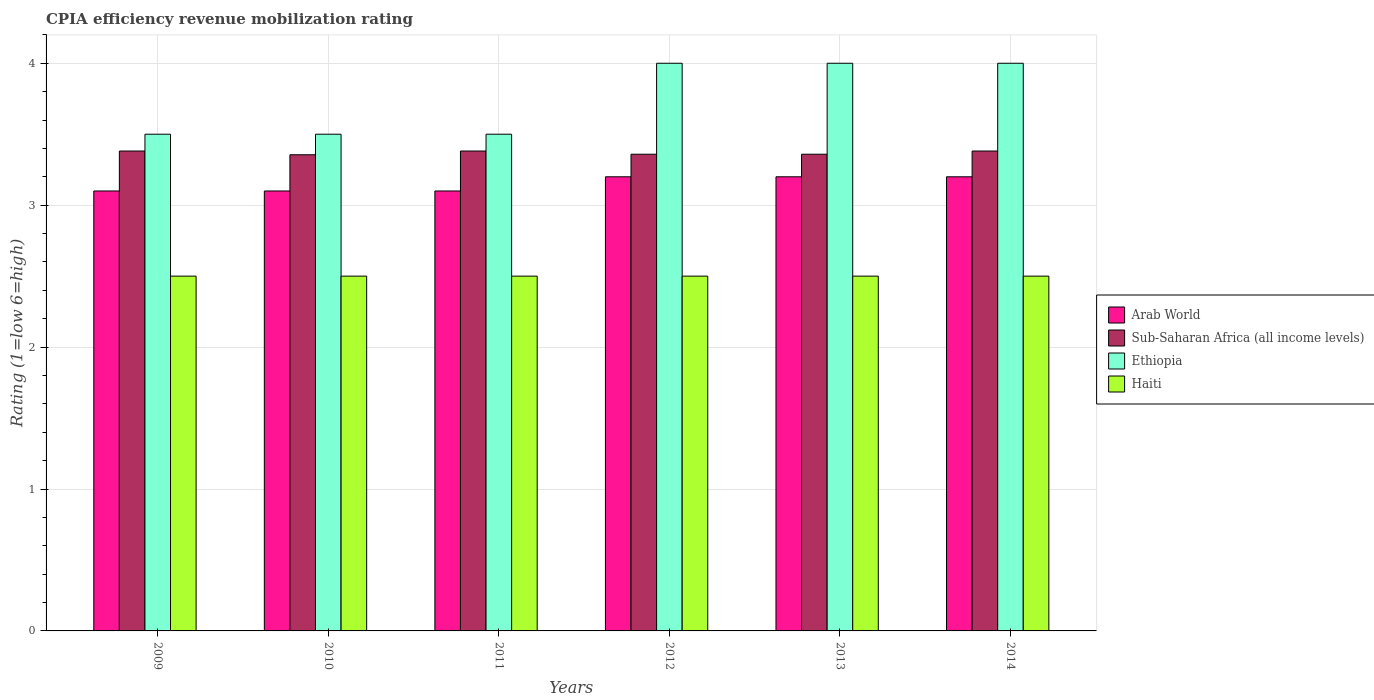How many different coloured bars are there?
Provide a short and direct response. 4. Are the number of bars per tick equal to the number of legend labels?
Give a very brief answer. Yes. Are the number of bars on each tick of the X-axis equal?
Provide a succinct answer. Yes. How many bars are there on the 6th tick from the right?
Provide a succinct answer. 4. What is the label of the 2nd group of bars from the left?
Your answer should be very brief. 2010. Across all years, what is the maximum CPIA rating in Sub-Saharan Africa (all income levels)?
Your response must be concise. 3.38. What is the total CPIA rating in Sub-Saharan Africa (all income levels) in the graph?
Provide a short and direct response. 20.22. What is the difference between the CPIA rating in Ethiopia in 2010 and that in 2012?
Your answer should be very brief. -0.5. What is the difference between the CPIA rating in Haiti in 2014 and the CPIA rating in Sub-Saharan Africa (all income levels) in 2009?
Your answer should be compact. -0.88. In how many years, is the CPIA rating in Sub-Saharan Africa (all income levels) greater than 3.2?
Offer a terse response. 6. What is the difference between the highest and the lowest CPIA rating in Arab World?
Make the answer very short. 0.1. In how many years, is the CPIA rating in Arab World greater than the average CPIA rating in Arab World taken over all years?
Keep it short and to the point. 3. Is it the case that in every year, the sum of the CPIA rating in Haiti and CPIA rating in Sub-Saharan Africa (all income levels) is greater than the sum of CPIA rating in Ethiopia and CPIA rating in Arab World?
Ensure brevity in your answer.  No. What does the 2nd bar from the left in 2014 represents?
Keep it short and to the point. Sub-Saharan Africa (all income levels). What does the 3rd bar from the right in 2012 represents?
Give a very brief answer. Sub-Saharan Africa (all income levels). Is it the case that in every year, the sum of the CPIA rating in Sub-Saharan Africa (all income levels) and CPIA rating in Arab World is greater than the CPIA rating in Haiti?
Make the answer very short. Yes. How many bars are there?
Ensure brevity in your answer.  24. What is the difference between two consecutive major ticks on the Y-axis?
Ensure brevity in your answer.  1. Are the values on the major ticks of Y-axis written in scientific E-notation?
Ensure brevity in your answer.  No. How many legend labels are there?
Give a very brief answer. 4. What is the title of the graph?
Ensure brevity in your answer.  CPIA efficiency revenue mobilization rating. Does "Uzbekistan" appear as one of the legend labels in the graph?
Give a very brief answer. No. What is the Rating (1=low 6=high) in Sub-Saharan Africa (all income levels) in 2009?
Give a very brief answer. 3.38. What is the Rating (1=low 6=high) of Ethiopia in 2009?
Ensure brevity in your answer.  3.5. What is the Rating (1=low 6=high) in Haiti in 2009?
Offer a very short reply. 2.5. What is the Rating (1=low 6=high) in Arab World in 2010?
Your answer should be compact. 3.1. What is the Rating (1=low 6=high) in Sub-Saharan Africa (all income levels) in 2010?
Offer a very short reply. 3.36. What is the Rating (1=low 6=high) of Sub-Saharan Africa (all income levels) in 2011?
Offer a very short reply. 3.38. What is the Rating (1=low 6=high) in Haiti in 2011?
Provide a short and direct response. 2.5. What is the Rating (1=low 6=high) of Sub-Saharan Africa (all income levels) in 2012?
Ensure brevity in your answer.  3.36. What is the Rating (1=low 6=high) of Ethiopia in 2012?
Your answer should be compact. 4. What is the Rating (1=low 6=high) of Arab World in 2013?
Make the answer very short. 3.2. What is the Rating (1=low 6=high) of Sub-Saharan Africa (all income levels) in 2013?
Your response must be concise. 3.36. What is the Rating (1=low 6=high) in Haiti in 2013?
Your answer should be compact. 2.5. What is the Rating (1=low 6=high) in Sub-Saharan Africa (all income levels) in 2014?
Your response must be concise. 3.38. Across all years, what is the maximum Rating (1=low 6=high) of Arab World?
Ensure brevity in your answer.  3.2. Across all years, what is the maximum Rating (1=low 6=high) of Sub-Saharan Africa (all income levels)?
Your answer should be compact. 3.38. Across all years, what is the maximum Rating (1=low 6=high) of Haiti?
Offer a very short reply. 2.5. Across all years, what is the minimum Rating (1=low 6=high) in Arab World?
Offer a very short reply. 3.1. Across all years, what is the minimum Rating (1=low 6=high) of Sub-Saharan Africa (all income levels)?
Your response must be concise. 3.36. Across all years, what is the minimum Rating (1=low 6=high) in Ethiopia?
Give a very brief answer. 3.5. Across all years, what is the minimum Rating (1=low 6=high) in Haiti?
Ensure brevity in your answer.  2.5. What is the total Rating (1=low 6=high) in Arab World in the graph?
Give a very brief answer. 18.9. What is the total Rating (1=low 6=high) in Sub-Saharan Africa (all income levels) in the graph?
Offer a very short reply. 20.22. What is the total Rating (1=low 6=high) in Haiti in the graph?
Keep it short and to the point. 15. What is the difference between the Rating (1=low 6=high) in Arab World in 2009 and that in 2010?
Keep it short and to the point. 0. What is the difference between the Rating (1=low 6=high) in Sub-Saharan Africa (all income levels) in 2009 and that in 2010?
Provide a short and direct response. 0.03. What is the difference between the Rating (1=low 6=high) in Ethiopia in 2009 and that in 2010?
Make the answer very short. 0. What is the difference between the Rating (1=low 6=high) of Ethiopia in 2009 and that in 2011?
Give a very brief answer. 0. What is the difference between the Rating (1=low 6=high) of Sub-Saharan Africa (all income levels) in 2009 and that in 2012?
Offer a terse response. 0.02. What is the difference between the Rating (1=low 6=high) in Haiti in 2009 and that in 2012?
Your answer should be very brief. 0. What is the difference between the Rating (1=low 6=high) in Arab World in 2009 and that in 2013?
Ensure brevity in your answer.  -0.1. What is the difference between the Rating (1=low 6=high) of Sub-Saharan Africa (all income levels) in 2009 and that in 2013?
Keep it short and to the point. 0.02. What is the difference between the Rating (1=low 6=high) of Ethiopia in 2009 and that in 2013?
Ensure brevity in your answer.  -0.5. What is the difference between the Rating (1=low 6=high) in Haiti in 2009 and that in 2013?
Provide a succinct answer. 0. What is the difference between the Rating (1=low 6=high) of Arab World in 2009 and that in 2014?
Provide a short and direct response. -0.1. What is the difference between the Rating (1=low 6=high) in Ethiopia in 2009 and that in 2014?
Offer a very short reply. -0.5. What is the difference between the Rating (1=low 6=high) in Haiti in 2009 and that in 2014?
Provide a succinct answer. 0. What is the difference between the Rating (1=low 6=high) of Sub-Saharan Africa (all income levels) in 2010 and that in 2011?
Your answer should be very brief. -0.03. What is the difference between the Rating (1=low 6=high) of Ethiopia in 2010 and that in 2011?
Ensure brevity in your answer.  0. What is the difference between the Rating (1=low 6=high) in Haiti in 2010 and that in 2011?
Your response must be concise. 0. What is the difference between the Rating (1=low 6=high) in Arab World in 2010 and that in 2012?
Your response must be concise. -0.1. What is the difference between the Rating (1=low 6=high) of Sub-Saharan Africa (all income levels) in 2010 and that in 2012?
Give a very brief answer. -0. What is the difference between the Rating (1=low 6=high) in Ethiopia in 2010 and that in 2012?
Ensure brevity in your answer.  -0.5. What is the difference between the Rating (1=low 6=high) of Haiti in 2010 and that in 2012?
Make the answer very short. 0. What is the difference between the Rating (1=low 6=high) of Sub-Saharan Africa (all income levels) in 2010 and that in 2013?
Your response must be concise. -0. What is the difference between the Rating (1=low 6=high) of Arab World in 2010 and that in 2014?
Give a very brief answer. -0.1. What is the difference between the Rating (1=low 6=high) in Sub-Saharan Africa (all income levels) in 2010 and that in 2014?
Offer a very short reply. -0.03. What is the difference between the Rating (1=low 6=high) of Ethiopia in 2010 and that in 2014?
Make the answer very short. -0.5. What is the difference between the Rating (1=low 6=high) in Sub-Saharan Africa (all income levels) in 2011 and that in 2012?
Your answer should be compact. 0.02. What is the difference between the Rating (1=low 6=high) in Haiti in 2011 and that in 2012?
Ensure brevity in your answer.  0. What is the difference between the Rating (1=low 6=high) of Arab World in 2011 and that in 2013?
Your response must be concise. -0.1. What is the difference between the Rating (1=low 6=high) of Sub-Saharan Africa (all income levels) in 2011 and that in 2013?
Keep it short and to the point. 0.02. What is the difference between the Rating (1=low 6=high) of Ethiopia in 2011 and that in 2013?
Your answer should be compact. -0.5. What is the difference between the Rating (1=low 6=high) of Sub-Saharan Africa (all income levels) in 2011 and that in 2014?
Offer a very short reply. 0. What is the difference between the Rating (1=low 6=high) of Sub-Saharan Africa (all income levels) in 2012 and that in 2013?
Your response must be concise. 0. What is the difference between the Rating (1=low 6=high) of Haiti in 2012 and that in 2013?
Provide a short and direct response. 0. What is the difference between the Rating (1=low 6=high) of Sub-Saharan Africa (all income levels) in 2012 and that in 2014?
Ensure brevity in your answer.  -0.02. What is the difference between the Rating (1=low 6=high) in Ethiopia in 2012 and that in 2014?
Your response must be concise. 0. What is the difference between the Rating (1=low 6=high) in Haiti in 2012 and that in 2014?
Keep it short and to the point. 0. What is the difference between the Rating (1=low 6=high) of Arab World in 2013 and that in 2014?
Make the answer very short. 0. What is the difference between the Rating (1=low 6=high) of Sub-Saharan Africa (all income levels) in 2013 and that in 2014?
Offer a terse response. -0.02. What is the difference between the Rating (1=low 6=high) of Ethiopia in 2013 and that in 2014?
Offer a very short reply. 0. What is the difference between the Rating (1=low 6=high) of Haiti in 2013 and that in 2014?
Give a very brief answer. 0. What is the difference between the Rating (1=low 6=high) of Arab World in 2009 and the Rating (1=low 6=high) of Sub-Saharan Africa (all income levels) in 2010?
Your answer should be compact. -0.26. What is the difference between the Rating (1=low 6=high) in Arab World in 2009 and the Rating (1=low 6=high) in Haiti in 2010?
Offer a terse response. 0.6. What is the difference between the Rating (1=low 6=high) of Sub-Saharan Africa (all income levels) in 2009 and the Rating (1=low 6=high) of Ethiopia in 2010?
Give a very brief answer. -0.12. What is the difference between the Rating (1=low 6=high) in Sub-Saharan Africa (all income levels) in 2009 and the Rating (1=low 6=high) in Haiti in 2010?
Provide a succinct answer. 0.88. What is the difference between the Rating (1=low 6=high) of Arab World in 2009 and the Rating (1=low 6=high) of Sub-Saharan Africa (all income levels) in 2011?
Your response must be concise. -0.28. What is the difference between the Rating (1=low 6=high) in Sub-Saharan Africa (all income levels) in 2009 and the Rating (1=low 6=high) in Ethiopia in 2011?
Your answer should be very brief. -0.12. What is the difference between the Rating (1=low 6=high) of Sub-Saharan Africa (all income levels) in 2009 and the Rating (1=low 6=high) of Haiti in 2011?
Make the answer very short. 0.88. What is the difference between the Rating (1=low 6=high) of Ethiopia in 2009 and the Rating (1=low 6=high) of Haiti in 2011?
Ensure brevity in your answer.  1. What is the difference between the Rating (1=low 6=high) of Arab World in 2009 and the Rating (1=low 6=high) of Sub-Saharan Africa (all income levels) in 2012?
Offer a terse response. -0.26. What is the difference between the Rating (1=low 6=high) of Arab World in 2009 and the Rating (1=low 6=high) of Ethiopia in 2012?
Ensure brevity in your answer.  -0.9. What is the difference between the Rating (1=low 6=high) of Sub-Saharan Africa (all income levels) in 2009 and the Rating (1=low 6=high) of Ethiopia in 2012?
Offer a very short reply. -0.62. What is the difference between the Rating (1=low 6=high) of Sub-Saharan Africa (all income levels) in 2009 and the Rating (1=low 6=high) of Haiti in 2012?
Offer a terse response. 0.88. What is the difference between the Rating (1=low 6=high) in Arab World in 2009 and the Rating (1=low 6=high) in Sub-Saharan Africa (all income levels) in 2013?
Make the answer very short. -0.26. What is the difference between the Rating (1=low 6=high) in Sub-Saharan Africa (all income levels) in 2009 and the Rating (1=low 6=high) in Ethiopia in 2013?
Your answer should be compact. -0.62. What is the difference between the Rating (1=low 6=high) of Sub-Saharan Africa (all income levels) in 2009 and the Rating (1=low 6=high) of Haiti in 2013?
Offer a very short reply. 0.88. What is the difference between the Rating (1=low 6=high) of Arab World in 2009 and the Rating (1=low 6=high) of Sub-Saharan Africa (all income levels) in 2014?
Keep it short and to the point. -0.28. What is the difference between the Rating (1=low 6=high) of Arab World in 2009 and the Rating (1=low 6=high) of Ethiopia in 2014?
Give a very brief answer. -0.9. What is the difference between the Rating (1=low 6=high) in Arab World in 2009 and the Rating (1=low 6=high) in Haiti in 2014?
Your answer should be very brief. 0.6. What is the difference between the Rating (1=low 6=high) in Sub-Saharan Africa (all income levels) in 2009 and the Rating (1=low 6=high) in Ethiopia in 2014?
Make the answer very short. -0.62. What is the difference between the Rating (1=low 6=high) of Sub-Saharan Africa (all income levels) in 2009 and the Rating (1=low 6=high) of Haiti in 2014?
Give a very brief answer. 0.88. What is the difference between the Rating (1=low 6=high) in Arab World in 2010 and the Rating (1=low 6=high) in Sub-Saharan Africa (all income levels) in 2011?
Your answer should be very brief. -0.28. What is the difference between the Rating (1=low 6=high) in Arab World in 2010 and the Rating (1=low 6=high) in Haiti in 2011?
Keep it short and to the point. 0.6. What is the difference between the Rating (1=low 6=high) of Sub-Saharan Africa (all income levels) in 2010 and the Rating (1=low 6=high) of Ethiopia in 2011?
Give a very brief answer. -0.14. What is the difference between the Rating (1=low 6=high) in Sub-Saharan Africa (all income levels) in 2010 and the Rating (1=low 6=high) in Haiti in 2011?
Make the answer very short. 0.86. What is the difference between the Rating (1=low 6=high) in Arab World in 2010 and the Rating (1=low 6=high) in Sub-Saharan Africa (all income levels) in 2012?
Offer a very short reply. -0.26. What is the difference between the Rating (1=low 6=high) in Sub-Saharan Africa (all income levels) in 2010 and the Rating (1=low 6=high) in Ethiopia in 2012?
Provide a succinct answer. -0.64. What is the difference between the Rating (1=low 6=high) of Sub-Saharan Africa (all income levels) in 2010 and the Rating (1=low 6=high) of Haiti in 2012?
Provide a succinct answer. 0.86. What is the difference between the Rating (1=low 6=high) of Ethiopia in 2010 and the Rating (1=low 6=high) of Haiti in 2012?
Keep it short and to the point. 1. What is the difference between the Rating (1=low 6=high) in Arab World in 2010 and the Rating (1=low 6=high) in Sub-Saharan Africa (all income levels) in 2013?
Keep it short and to the point. -0.26. What is the difference between the Rating (1=low 6=high) in Arab World in 2010 and the Rating (1=low 6=high) in Ethiopia in 2013?
Make the answer very short. -0.9. What is the difference between the Rating (1=low 6=high) of Sub-Saharan Africa (all income levels) in 2010 and the Rating (1=low 6=high) of Ethiopia in 2013?
Your answer should be very brief. -0.64. What is the difference between the Rating (1=low 6=high) of Sub-Saharan Africa (all income levels) in 2010 and the Rating (1=low 6=high) of Haiti in 2013?
Make the answer very short. 0.86. What is the difference between the Rating (1=low 6=high) in Arab World in 2010 and the Rating (1=low 6=high) in Sub-Saharan Africa (all income levels) in 2014?
Provide a short and direct response. -0.28. What is the difference between the Rating (1=low 6=high) of Arab World in 2010 and the Rating (1=low 6=high) of Haiti in 2014?
Keep it short and to the point. 0.6. What is the difference between the Rating (1=low 6=high) in Sub-Saharan Africa (all income levels) in 2010 and the Rating (1=low 6=high) in Ethiopia in 2014?
Give a very brief answer. -0.64. What is the difference between the Rating (1=low 6=high) in Sub-Saharan Africa (all income levels) in 2010 and the Rating (1=low 6=high) in Haiti in 2014?
Your answer should be compact. 0.86. What is the difference between the Rating (1=low 6=high) in Arab World in 2011 and the Rating (1=low 6=high) in Sub-Saharan Africa (all income levels) in 2012?
Give a very brief answer. -0.26. What is the difference between the Rating (1=low 6=high) in Arab World in 2011 and the Rating (1=low 6=high) in Ethiopia in 2012?
Provide a succinct answer. -0.9. What is the difference between the Rating (1=low 6=high) in Sub-Saharan Africa (all income levels) in 2011 and the Rating (1=low 6=high) in Ethiopia in 2012?
Provide a short and direct response. -0.62. What is the difference between the Rating (1=low 6=high) of Sub-Saharan Africa (all income levels) in 2011 and the Rating (1=low 6=high) of Haiti in 2012?
Keep it short and to the point. 0.88. What is the difference between the Rating (1=low 6=high) of Arab World in 2011 and the Rating (1=low 6=high) of Sub-Saharan Africa (all income levels) in 2013?
Provide a succinct answer. -0.26. What is the difference between the Rating (1=low 6=high) of Arab World in 2011 and the Rating (1=low 6=high) of Haiti in 2013?
Offer a very short reply. 0.6. What is the difference between the Rating (1=low 6=high) of Sub-Saharan Africa (all income levels) in 2011 and the Rating (1=low 6=high) of Ethiopia in 2013?
Give a very brief answer. -0.62. What is the difference between the Rating (1=low 6=high) of Sub-Saharan Africa (all income levels) in 2011 and the Rating (1=low 6=high) of Haiti in 2013?
Your answer should be compact. 0.88. What is the difference between the Rating (1=low 6=high) in Ethiopia in 2011 and the Rating (1=low 6=high) in Haiti in 2013?
Give a very brief answer. 1. What is the difference between the Rating (1=low 6=high) of Arab World in 2011 and the Rating (1=low 6=high) of Sub-Saharan Africa (all income levels) in 2014?
Your answer should be very brief. -0.28. What is the difference between the Rating (1=low 6=high) in Arab World in 2011 and the Rating (1=low 6=high) in Haiti in 2014?
Keep it short and to the point. 0.6. What is the difference between the Rating (1=low 6=high) in Sub-Saharan Africa (all income levels) in 2011 and the Rating (1=low 6=high) in Ethiopia in 2014?
Provide a short and direct response. -0.62. What is the difference between the Rating (1=low 6=high) in Sub-Saharan Africa (all income levels) in 2011 and the Rating (1=low 6=high) in Haiti in 2014?
Keep it short and to the point. 0.88. What is the difference between the Rating (1=low 6=high) of Ethiopia in 2011 and the Rating (1=low 6=high) of Haiti in 2014?
Ensure brevity in your answer.  1. What is the difference between the Rating (1=low 6=high) in Arab World in 2012 and the Rating (1=low 6=high) in Sub-Saharan Africa (all income levels) in 2013?
Provide a succinct answer. -0.16. What is the difference between the Rating (1=low 6=high) in Sub-Saharan Africa (all income levels) in 2012 and the Rating (1=low 6=high) in Ethiopia in 2013?
Provide a succinct answer. -0.64. What is the difference between the Rating (1=low 6=high) in Sub-Saharan Africa (all income levels) in 2012 and the Rating (1=low 6=high) in Haiti in 2013?
Provide a succinct answer. 0.86. What is the difference between the Rating (1=low 6=high) of Ethiopia in 2012 and the Rating (1=low 6=high) of Haiti in 2013?
Offer a terse response. 1.5. What is the difference between the Rating (1=low 6=high) of Arab World in 2012 and the Rating (1=low 6=high) of Sub-Saharan Africa (all income levels) in 2014?
Offer a very short reply. -0.18. What is the difference between the Rating (1=low 6=high) in Arab World in 2012 and the Rating (1=low 6=high) in Ethiopia in 2014?
Ensure brevity in your answer.  -0.8. What is the difference between the Rating (1=low 6=high) in Arab World in 2012 and the Rating (1=low 6=high) in Haiti in 2014?
Provide a short and direct response. 0.7. What is the difference between the Rating (1=low 6=high) in Sub-Saharan Africa (all income levels) in 2012 and the Rating (1=low 6=high) in Ethiopia in 2014?
Offer a very short reply. -0.64. What is the difference between the Rating (1=low 6=high) of Sub-Saharan Africa (all income levels) in 2012 and the Rating (1=low 6=high) of Haiti in 2014?
Give a very brief answer. 0.86. What is the difference between the Rating (1=low 6=high) of Ethiopia in 2012 and the Rating (1=low 6=high) of Haiti in 2014?
Your answer should be very brief. 1.5. What is the difference between the Rating (1=low 6=high) of Arab World in 2013 and the Rating (1=low 6=high) of Sub-Saharan Africa (all income levels) in 2014?
Provide a short and direct response. -0.18. What is the difference between the Rating (1=low 6=high) in Arab World in 2013 and the Rating (1=low 6=high) in Ethiopia in 2014?
Provide a short and direct response. -0.8. What is the difference between the Rating (1=low 6=high) in Sub-Saharan Africa (all income levels) in 2013 and the Rating (1=low 6=high) in Ethiopia in 2014?
Your response must be concise. -0.64. What is the difference between the Rating (1=low 6=high) of Sub-Saharan Africa (all income levels) in 2013 and the Rating (1=low 6=high) of Haiti in 2014?
Ensure brevity in your answer.  0.86. What is the average Rating (1=low 6=high) of Arab World per year?
Offer a very short reply. 3.15. What is the average Rating (1=low 6=high) in Sub-Saharan Africa (all income levels) per year?
Your answer should be very brief. 3.37. What is the average Rating (1=low 6=high) in Ethiopia per year?
Offer a very short reply. 3.75. In the year 2009, what is the difference between the Rating (1=low 6=high) in Arab World and Rating (1=low 6=high) in Sub-Saharan Africa (all income levels)?
Your answer should be compact. -0.28. In the year 2009, what is the difference between the Rating (1=low 6=high) in Arab World and Rating (1=low 6=high) in Ethiopia?
Provide a short and direct response. -0.4. In the year 2009, what is the difference between the Rating (1=low 6=high) of Arab World and Rating (1=low 6=high) of Haiti?
Your response must be concise. 0.6. In the year 2009, what is the difference between the Rating (1=low 6=high) of Sub-Saharan Africa (all income levels) and Rating (1=low 6=high) of Ethiopia?
Your answer should be very brief. -0.12. In the year 2009, what is the difference between the Rating (1=low 6=high) in Sub-Saharan Africa (all income levels) and Rating (1=low 6=high) in Haiti?
Offer a very short reply. 0.88. In the year 2009, what is the difference between the Rating (1=low 6=high) in Ethiopia and Rating (1=low 6=high) in Haiti?
Keep it short and to the point. 1. In the year 2010, what is the difference between the Rating (1=low 6=high) of Arab World and Rating (1=low 6=high) of Sub-Saharan Africa (all income levels)?
Offer a very short reply. -0.26. In the year 2010, what is the difference between the Rating (1=low 6=high) in Arab World and Rating (1=low 6=high) in Haiti?
Keep it short and to the point. 0.6. In the year 2010, what is the difference between the Rating (1=low 6=high) of Sub-Saharan Africa (all income levels) and Rating (1=low 6=high) of Ethiopia?
Give a very brief answer. -0.14. In the year 2010, what is the difference between the Rating (1=low 6=high) in Sub-Saharan Africa (all income levels) and Rating (1=low 6=high) in Haiti?
Make the answer very short. 0.86. In the year 2011, what is the difference between the Rating (1=low 6=high) in Arab World and Rating (1=low 6=high) in Sub-Saharan Africa (all income levels)?
Keep it short and to the point. -0.28. In the year 2011, what is the difference between the Rating (1=low 6=high) of Arab World and Rating (1=low 6=high) of Haiti?
Your response must be concise. 0.6. In the year 2011, what is the difference between the Rating (1=low 6=high) of Sub-Saharan Africa (all income levels) and Rating (1=low 6=high) of Ethiopia?
Provide a short and direct response. -0.12. In the year 2011, what is the difference between the Rating (1=low 6=high) of Sub-Saharan Africa (all income levels) and Rating (1=low 6=high) of Haiti?
Your answer should be very brief. 0.88. In the year 2012, what is the difference between the Rating (1=low 6=high) of Arab World and Rating (1=low 6=high) of Sub-Saharan Africa (all income levels)?
Give a very brief answer. -0.16. In the year 2012, what is the difference between the Rating (1=low 6=high) in Arab World and Rating (1=low 6=high) in Ethiopia?
Your answer should be very brief. -0.8. In the year 2012, what is the difference between the Rating (1=low 6=high) of Arab World and Rating (1=low 6=high) of Haiti?
Provide a short and direct response. 0.7. In the year 2012, what is the difference between the Rating (1=low 6=high) in Sub-Saharan Africa (all income levels) and Rating (1=low 6=high) in Ethiopia?
Give a very brief answer. -0.64. In the year 2012, what is the difference between the Rating (1=low 6=high) of Sub-Saharan Africa (all income levels) and Rating (1=low 6=high) of Haiti?
Keep it short and to the point. 0.86. In the year 2012, what is the difference between the Rating (1=low 6=high) of Ethiopia and Rating (1=low 6=high) of Haiti?
Give a very brief answer. 1.5. In the year 2013, what is the difference between the Rating (1=low 6=high) in Arab World and Rating (1=low 6=high) in Sub-Saharan Africa (all income levels)?
Offer a very short reply. -0.16. In the year 2013, what is the difference between the Rating (1=low 6=high) of Sub-Saharan Africa (all income levels) and Rating (1=low 6=high) of Ethiopia?
Your response must be concise. -0.64. In the year 2013, what is the difference between the Rating (1=low 6=high) of Sub-Saharan Africa (all income levels) and Rating (1=low 6=high) of Haiti?
Give a very brief answer. 0.86. In the year 2013, what is the difference between the Rating (1=low 6=high) in Ethiopia and Rating (1=low 6=high) in Haiti?
Your answer should be very brief. 1.5. In the year 2014, what is the difference between the Rating (1=low 6=high) in Arab World and Rating (1=low 6=high) in Sub-Saharan Africa (all income levels)?
Keep it short and to the point. -0.18. In the year 2014, what is the difference between the Rating (1=low 6=high) in Arab World and Rating (1=low 6=high) in Ethiopia?
Make the answer very short. -0.8. In the year 2014, what is the difference between the Rating (1=low 6=high) of Sub-Saharan Africa (all income levels) and Rating (1=low 6=high) of Ethiopia?
Keep it short and to the point. -0.62. In the year 2014, what is the difference between the Rating (1=low 6=high) in Sub-Saharan Africa (all income levels) and Rating (1=low 6=high) in Haiti?
Make the answer very short. 0.88. In the year 2014, what is the difference between the Rating (1=low 6=high) of Ethiopia and Rating (1=low 6=high) of Haiti?
Offer a very short reply. 1.5. What is the ratio of the Rating (1=low 6=high) of Haiti in 2009 to that in 2010?
Your answer should be compact. 1. What is the ratio of the Rating (1=low 6=high) in Arab World in 2009 to that in 2011?
Offer a very short reply. 1. What is the ratio of the Rating (1=low 6=high) of Arab World in 2009 to that in 2012?
Provide a short and direct response. 0.97. What is the ratio of the Rating (1=low 6=high) of Sub-Saharan Africa (all income levels) in 2009 to that in 2012?
Provide a succinct answer. 1.01. What is the ratio of the Rating (1=low 6=high) of Ethiopia in 2009 to that in 2012?
Offer a terse response. 0.88. What is the ratio of the Rating (1=low 6=high) of Haiti in 2009 to that in 2012?
Your response must be concise. 1. What is the ratio of the Rating (1=low 6=high) of Arab World in 2009 to that in 2013?
Your answer should be very brief. 0.97. What is the ratio of the Rating (1=low 6=high) of Sub-Saharan Africa (all income levels) in 2009 to that in 2013?
Your answer should be very brief. 1.01. What is the ratio of the Rating (1=low 6=high) of Ethiopia in 2009 to that in 2013?
Make the answer very short. 0.88. What is the ratio of the Rating (1=low 6=high) in Haiti in 2009 to that in 2013?
Keep it short and to the point. 1. What is the ratio of the Rating (1=low 6=high) in Arab World in 2009 to that in 2014?
Provide a short and direct response. 0.97. What is the ratio of the Rating (1=low 6=high) of Ethiopia in 2009 to that in 2014?
Provide a short and direct response. 0.88. What is the ratio of the Rating (1=low 6=high) in Haiti in 2009 to that in 2014?
Provide a short and direct response. 1. What is the ratio of the Rating (1=low 6=high) in Arab World in 2010 to that in 2011?
Your response must be concise. 1. What is the ratio of the Rating (1=low 6=high) of Sub-Saharan Africa (all income levels) in 2010 to that in 2011?
Offer a very short reply. 0.99. What is the ratio of the Rating (1=low 6=high) in Ethiopia in 2010 to that in 2011?
Your response must be concise. 1. What is the ratio of the Rating (1=low 6=high) of Haiti in 2010 to that in 2011?
Make the answer very short. 1. What is the ratio of the Rating (1=low 6=high) of Arab World in 2010 to that in 2012?
Ensure brevity in your answer.  0.97. What is the ratio of the Rating (1=low 6=high) of Sub-Saharan Africa (all income levels) in 2010 to that in 2012?
Provide a succinct answer. 1. What is the ratio of the Rating (1=low 6=high) in Ethiopia in 2010 to that in 2012?
Give a very brief answer. 0.88. What is the ratio of the Rating (1=low 6=high) of Haiti in 2010 to that in 2012?
Keep it short and to the point. 1. What is the ratio of the Rating (1=low 6=high) in Arab World in 2010 to that in 2013?
Provide a short and direct response. 0.97. What is the ratio of the Rating (1=low 6=high) of Arab World in 2010 to that in 2014?
Offer a terse response. 0.97. What is the ratio of the Rating (1=low 6=high) in Sub-Saharan Africa (all income levels) in 2010 to that in 2014?
Your answer should be compact. 0.99. What is the ratio of the Rating (1=low 6=high) of Haiti in 2010 to that in 2014?
Your answer should be very brief. 1. What is the ratio of the Rating (1=low 6=high) in Arab World in 2011 to that in 2012?
Your answer should be compact. 0.97. What is the ratio of the Rating (1=low 6=high) in Ethiopia in 2011 to that in 2012?
Your answer should be very brief. 0.88. What is the ratio of the Rating (1=low 6=high) of Haiti in 2011 to that in 2012?
Offer a terse response. 1. What is the ratio of the Rating (1=low 6=high) in Arab World in 2011 to that in 2013?
Your response must be concise. 0.97. What is the ratio of the Rating (1=low 6=high) of Sub-Saharan Africa (all income levels) in 2011 to that in 2013?
Your answer should be very brief. 1.01. What is the ratio of the Rating (1=low 6=high) of Haiti in 2011 to that in 2013?
Your answer should be compact. 1. What is the ratio of the Rating (1=low 6=high) in Arab World in 2011 to that in 2014?
Ensure brevity in your answer.  0.97. What is the ratio of the Rating (1=low 6=high) of Sub-Saharan Africa (all income levels) in 2011 to that in 2014?
Your answer should be compact. 1. What is the ratio of the Rating (1=low 6=high) of Haiti in 2011 to that in 2014?
Provide a succinct answer. 1. What is the ratio of the Rating (1=low 6=high) of Ethiopia in 2012 to that in 2013?
Make the answer very short. 1. What is the ratio of the Rating (1=low 6=high) in Haiti in 2012 to that in 2013?
Offer a terse response. 1. What is the ratio of the Rating (1=low 6=high) of Arab World in 2012 to that in 2014?
Offer a terse response. 1. What is the ratio of the Rating (1=low 6=high) in Sub-Saharan Africa (all income levels) in 2012 to that in 2014?
Offer a very short reply. 0.99. What is the ratio of the Rating (1=low 6=high) in Ethiopia in 2012 to that in 2014?
Provide a short and direct response. 1. What is the ratio of the Rating (1=low 6=high) in Haiti in 2012 to that in 2014?
Keep it short and to the point. 1. What is the ratio of the Rating (1=low 6=high) in Sub-Saharan Africa (all income levels) in 2013 to that in 2014?
Keep it short and to the point. 0.99. What is the ratio of the Rating (1=low 6=high) of Ethiopia in 2013 to that in 2014?
Ensure brevity in your answer.  1. What is the difference between the highest and the second highest Rating (1=low 6=high) in Haiti?
Keep it short and to the point. 0. What is the difference between the highest and the lowest Rating (1=low 6=high) of Sub-Saharan Africa (all income levels)?
Provide a succinct answer. 0.03. What is the difference between the highest and the lowest Rating (1=low 6=high) of Ethiopia?
Provide a short and direct response. 0.5. 